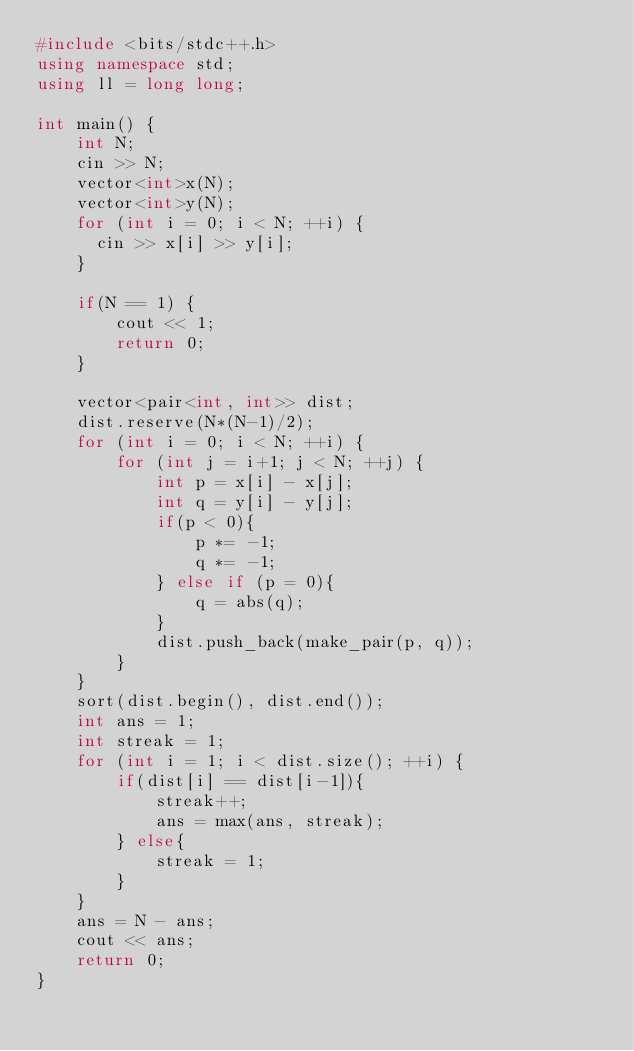<code> <loc_0><loc_0><loc_500><loc_500><_C++_>#include <bits/stdc++.h>
using namespace std;
using ll = long long;

int main() {
    int N;
    cin >> N;
    vector<int>x(N);
    vector<int>y(N);
    for (int i = 0; i < N; ++i) {
      cin >> x[i] >> y[i];
    }

    if(N == 1) {
        cout << 1;
        return 0;
    }

    vector<pair<int, int>> dist;
    dist.reserve(N*(N-1)/2);
    for (int i = 0; i < N; ++i) {
        for (int j = i+1; j < N; ++j) {
            int p = x[i] - x[j];
            int q = y[i] - y[j];
            if(p < 0){
                p *= -1;
                q *= -1;
            } else if (p = 0){
                q = abs(q);
            }
            dist.push_back(make_pair(p, q));
        }
    }
    sort(dist.begin(), dist.end());
    int ans = 1;
    int streak = 1;
    for (int i = 1; i < dist.size(); ++i) {
        if(dist[i] == dist[i-1]){
            streak++;
            ans = max(ans, streak);
        } else{
            streak = 1;
        }
    }
    ans = N - ans;
    cout << ans;
    return 0;
}</code> 